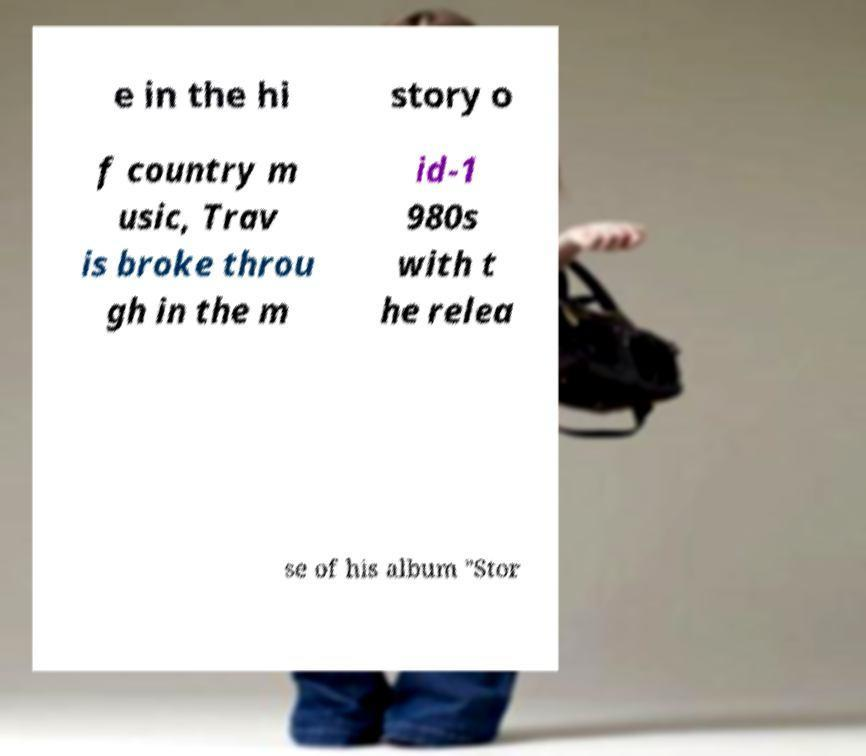Please identify and transcribe the text found in this image. e in the hi story o f country m usic, Trav is broke throu gh in the m id-1 980s with t he relea se of his album "Stor 